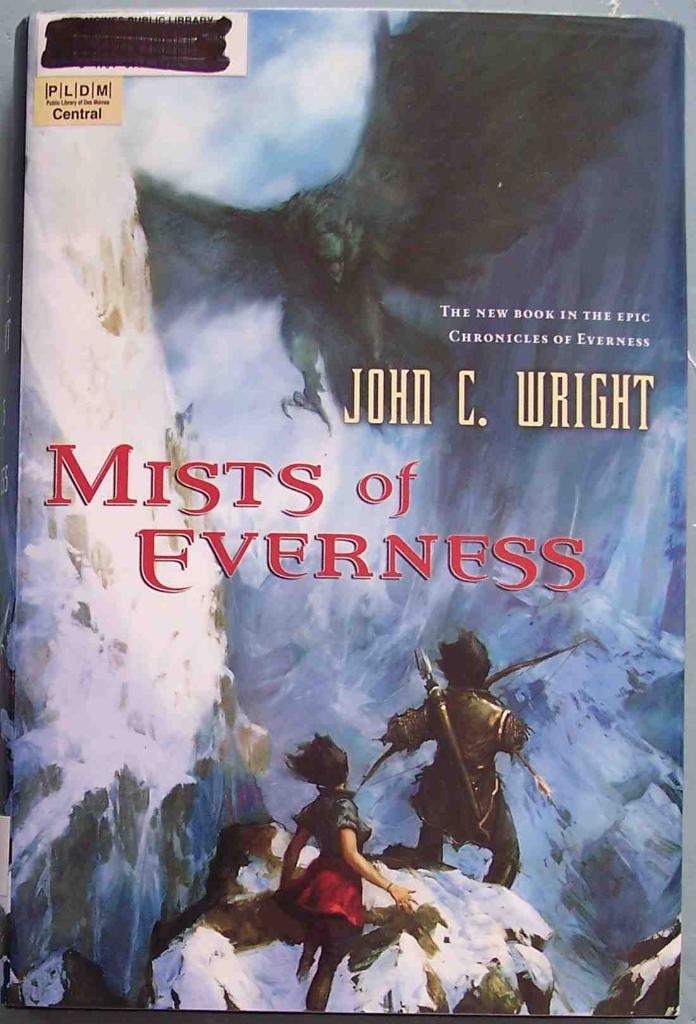<image>
Offer a succinct explanation of the picture presented. a book called 'mists of everness' by john c. wright 